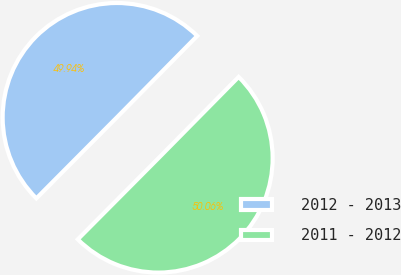Convert chart. <chart><loc_0><loc_0><loc_500><loc_500><pie_chart><fcel>2012 - 2013<fcel>2011 - 2012<nl><fcel>49.94%<fcel>50.06%<nl></chart> 